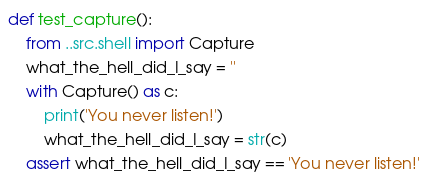Convert code to text. <code><loc_0><loc_0><loc_500><loc_500><_Python_>def test_capture():
    from ..src.shell import Capture
    what_the_hell_did_I_say = ''
    with Capture() as c:
        print('You never listen!')
        what_the_hell_did_I_say = str(c)
    assert what_the_hell_did_I_say == 'You never listen!'
</code> 